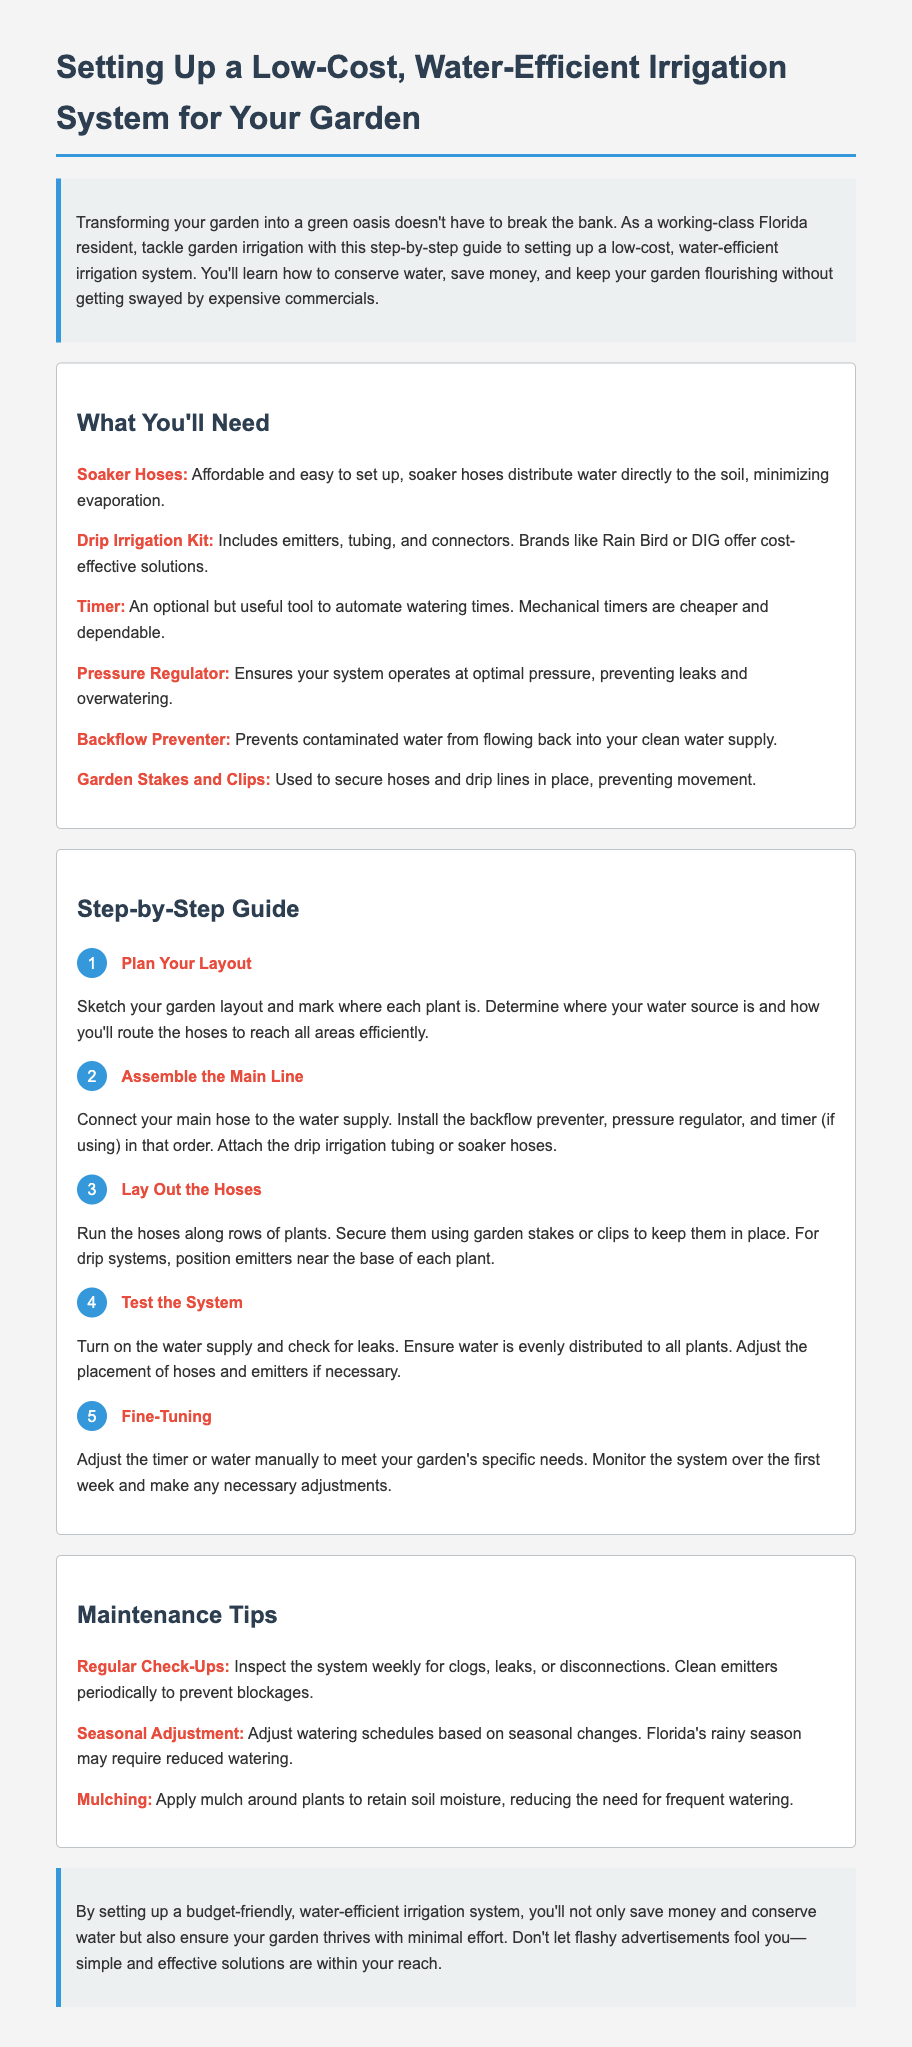What is the first step in setting up the irrigation system? The first step outlined in the document is to plan your layout by sketching your garden layout and marking where each plant is.
Answer: Plan Your Layout Which material is optional for the irrigation setup? The document mentions that a timer is an optional tool for automating watering times.
Answer: Timer What type of hoses are mentioned for efficient watering? The document states that soaker hoses are affordable and easy to set up, distributing water directly to the soil.
Answer: Soaker Hoses What should you check for during the testing phase? During the test of the system, it is important to check for leaks and to ensure that water is evenly distributed to all plants.
Answer: Leaks How often should the system be inspected? The maintenance tips section advises inspecting the system weekly for clogs, leaks, or disconnections.
Answer: Weekly What is one way to conserve moisture in the garden? The document suggests applying mulch around plants to retain soil moisture, reducing watering frequency.
Answer: Mulching What should you do after the first week of use? It is recommended to monitor the system over the first week and make any necessary adjustments.
Answer: Adjustments What is a primary benefit of using a pressure regulator? A pressure regulator ensures the system operates at optimal pressure, which prevents leaks and overwatering.
Answer: Preventing leaks Which type of irrigation kit is mentioned as cost-effective? The document notes that a drip irrigation kit, including emitters, tubing, and connectors, is a cost-effective solution.
Answer: Drip Irrigation Kit 